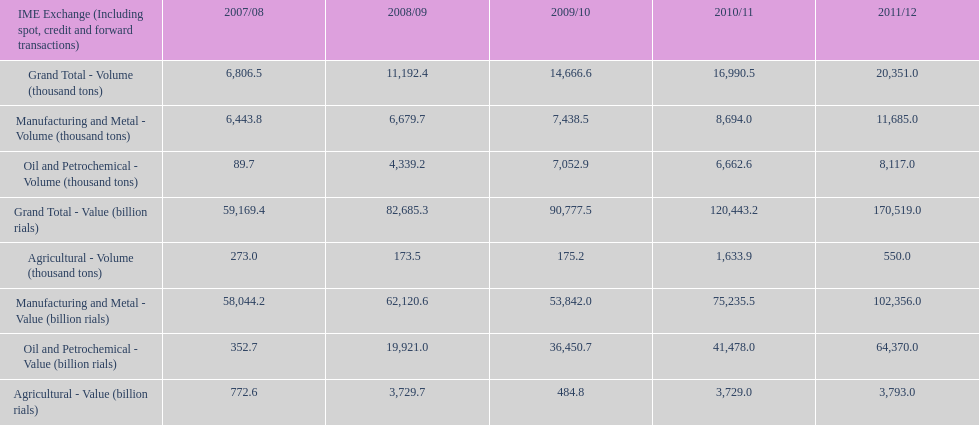Did 2010/11 or 2011/12 make more in grand total value? 2011/12. 